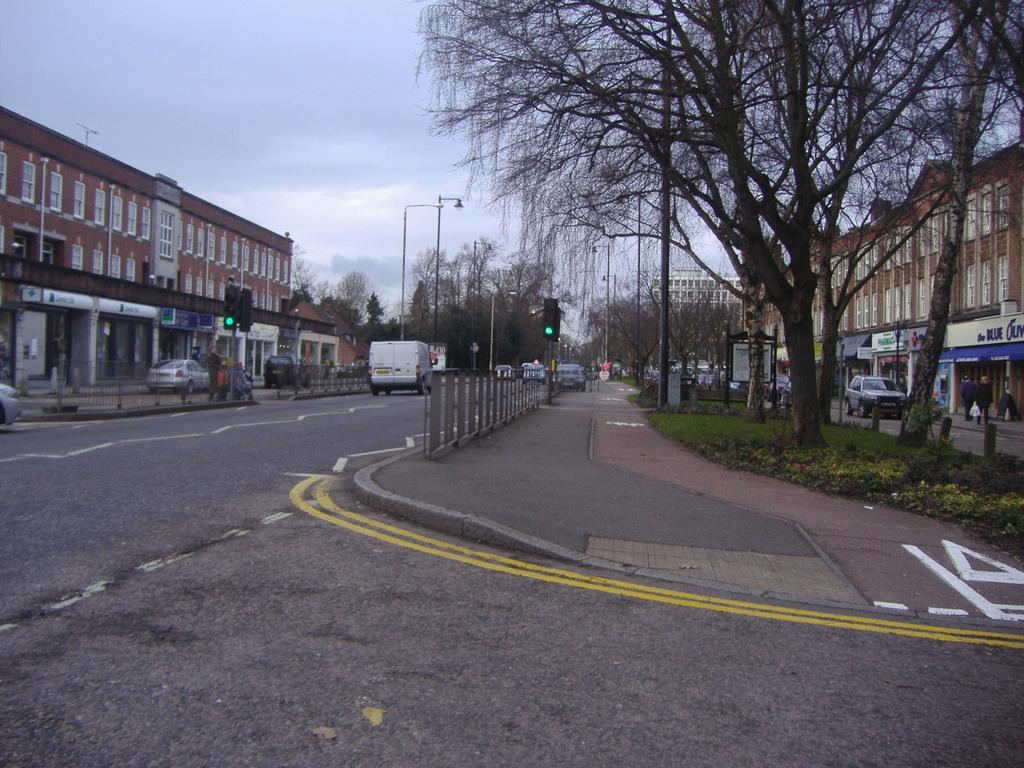Can you describe this image briefly? In this picture we can observe a railing and a traffic signal fixed to the pole. There is a road and a footpath. We can observe some plants and tree here. There are some street light poles and vehicles moving on the road. There are building on either sides of the road. In the background there is a sky with some clouds. 